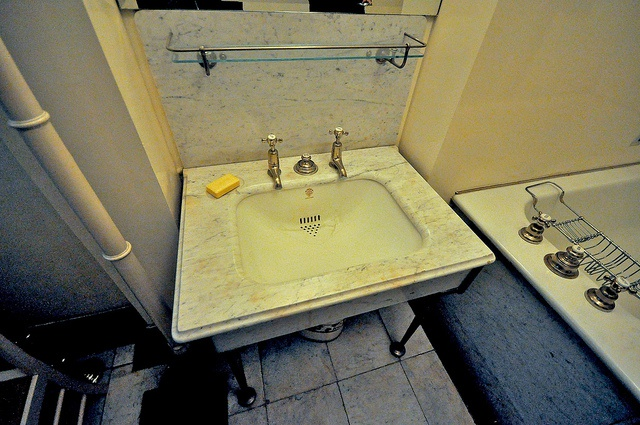Describe the objects in this image and their specific colors. I can see a sink in gray, tan, and khaki tones in this image. 